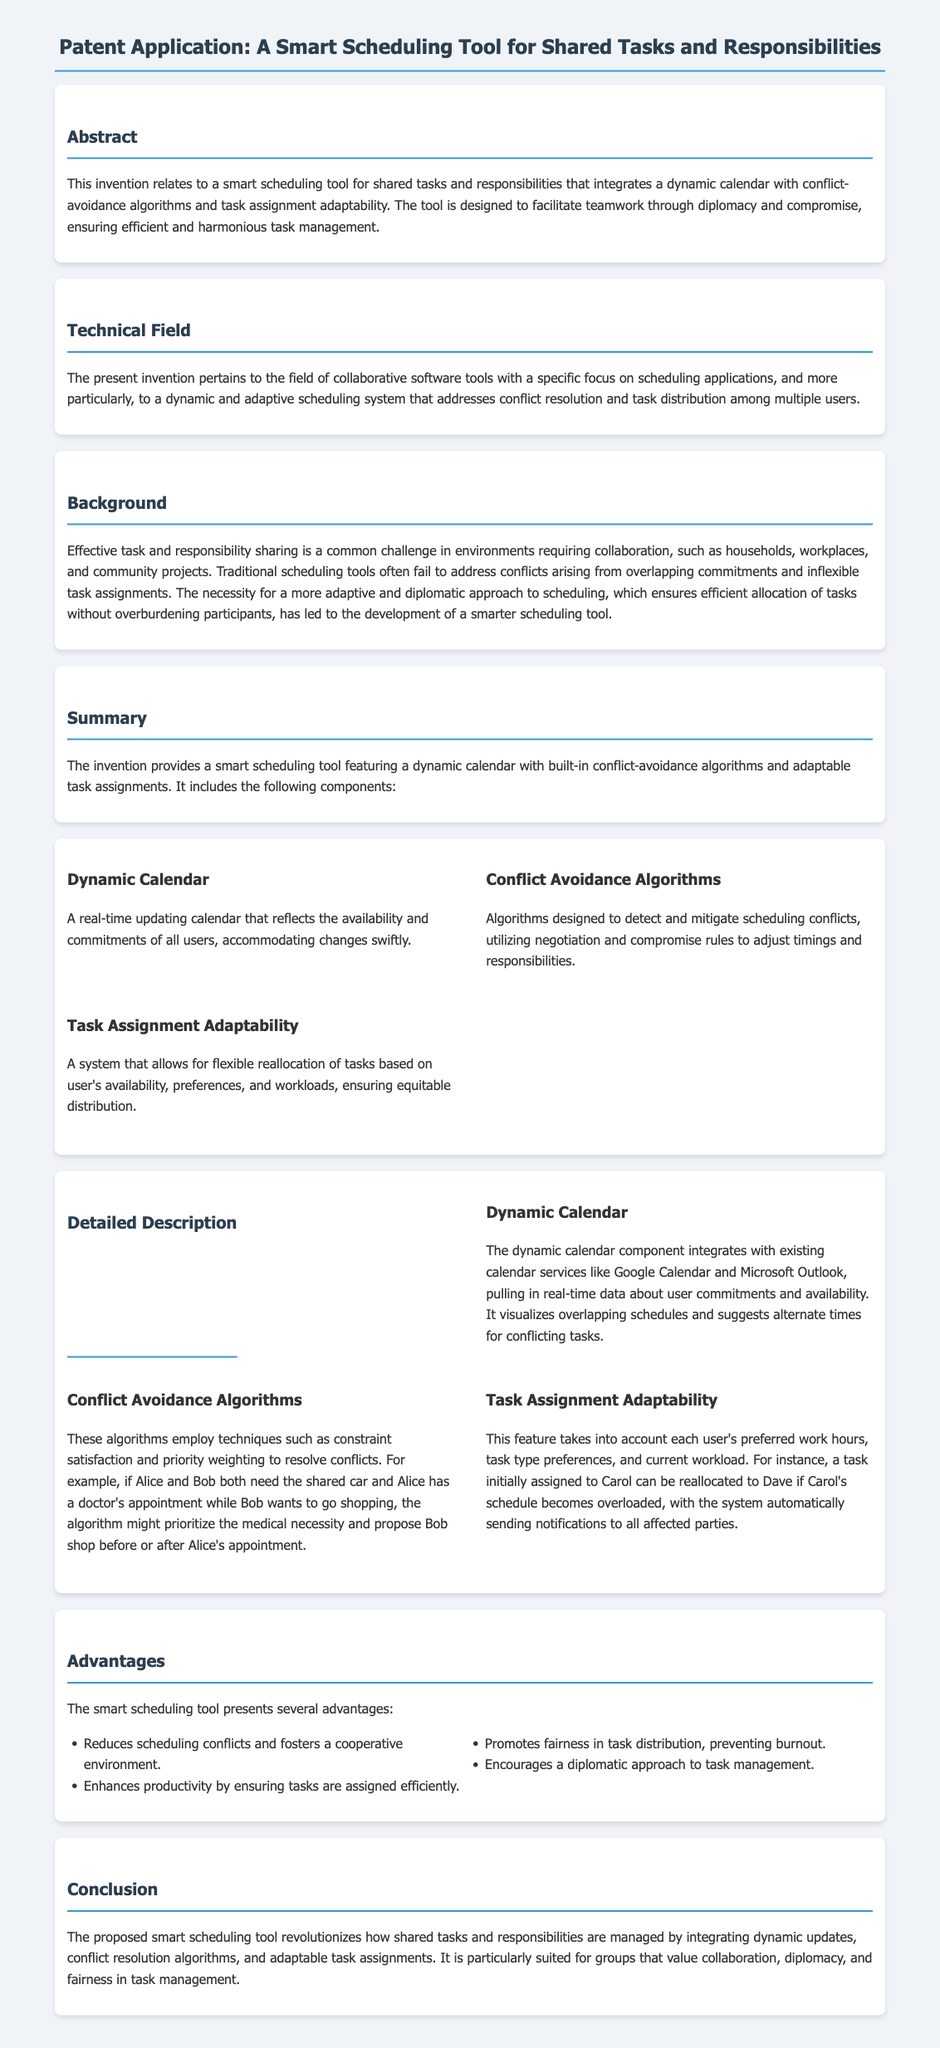What is the title of the patent application? The title is found at the beginning of the document, which states the subject of the invention.
Answer: A Smart Scheduling Tool for Shared Tasks and Responsibilities What are the main components of the smart scheduling tool? The main components are outlined in the summary section of the document, detailing the key features included.
Answer: Dynamic Calendar, Conflict Avoidance Algorithms, Task Assignment Adaptability How does the dynamic calendar integrate with existing services? The detailed description of the dynamic calendar specifies its interaction with various calendar services, confirming its compatibility for real-time updates.
Answer: Google Calendar and Microsoft Outlook What is the purpose of conflict avoidance algorithms? The document explains that these algorithms aim to mitigate scheduling conflicts by using certain techniques and negotiation methods.
Answer: Detecting and mitigating scheduling conflicts What advantage does the tool promote in task distribution? An advantage listed in the document indicates the tool encourages a specific approach to fair task management, reflecting its intention.
Answer: Fairness in task distribution Which environments can benefit from the smart scheduling tool? The background section suggests multiple collaborative environments that face task sharing challenges.
Answer: Households, workplaces, and community projects What is the primary goal of the proposed tool? The conclusion of the document summarizes the tool's main objective regarding shared task management, encapsulating its overall intention.
Answer: Revolutionizes how shared tasks and responsibilities are managed In what technical field does this invention belong? The technical field section provides a specific classification of the type of technology associated with this invention.
Answer: Collaborative software tools What is the role of task assignment adaptability? The detailed description discusses how this feature works to ensure equitable distribution among users based on individual factors.
Answer: Flexible reallocation of tasks 